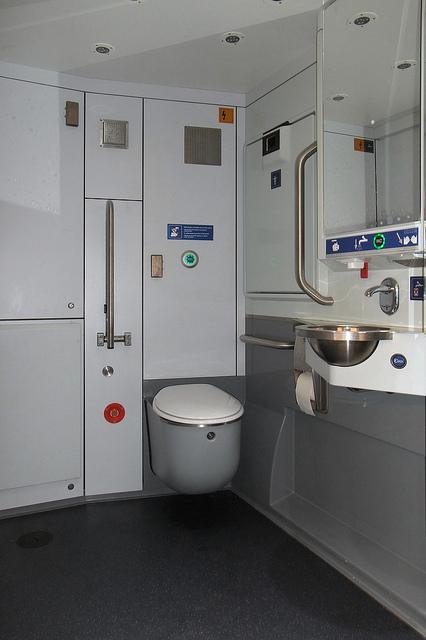What material is the sink made of?
Short answer required. Metal. What is decorating the walls?
Be succinct. Stickers. What type of room is this?
Concise answer only. Bathroom. Where is the toilet?
Be succinct. Back wall. 